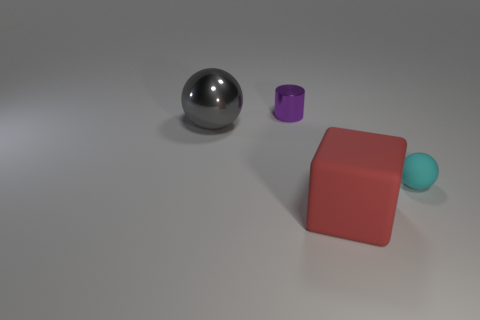Add 4 cyan things. How many objects exist? 8 Add 2 tiny metal cylinders. How many tiny metal cylinders exist? 3 Subtract 0 blue spheres. How many objects are left? 4 Subtract all tiny metallic objects. Subtract all large rubber cubes. How many objects are left? 2 Add 3 metal cylinders. How many metal cylinders are left? 4 